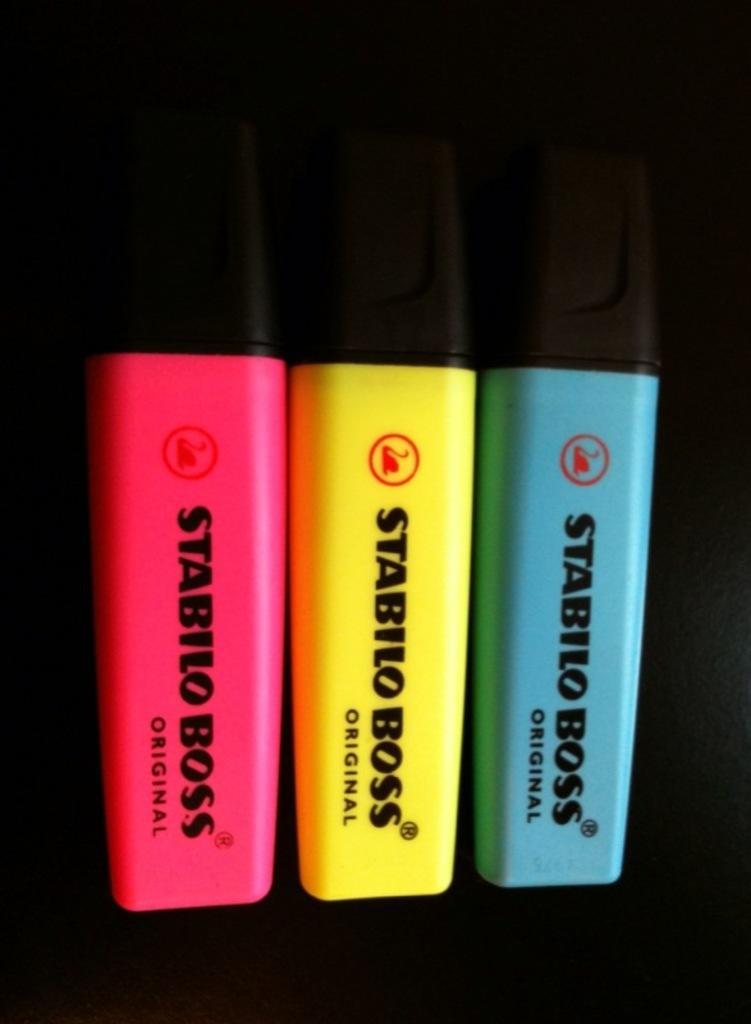In one or two sentences, can you explain what this image depicts? In this image I can see three sketches, they are in green, yellow and pink color and I can see dark background. 